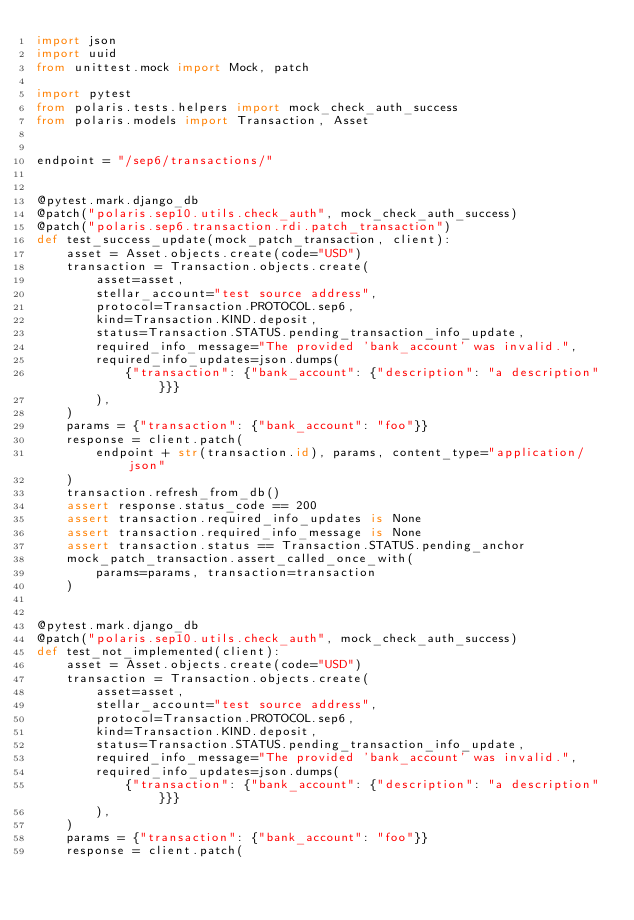<code> <loc_0><loc_0><loc_500><loc_500><_Python_>import json
import uuid
from unittest.mock import Mock, patch

import pytest
from polaris.tests.helpers import mock_check_auth_success
from polaris.models import Transaction, Asset


endpoint = "/sep6/transactions/"


@pytest.mark.django_db
@patch("polaris.sep10.utils.check_auth", mock_check_auth_success)
@patch("polaris.sep6.transaction.rdi.patch_transaction")
def test_success_update(mock_patch_transaction, client):
    asset = Asset.objects.create(code="USD")
    transaction = Transaction.objects.create(
        asset=asset,
        stellar_account="test source address",
        protocol=Transaction.PROTOCOL.sep6,
        kind=Transaction.KIND.deposit,
        status=Transaction.STATUS.pending_transaction_info_update,
        required_info_message="The provided 'bank_account' was invalid.",
        required_info_updates=json.dumps(
            {"transaction": {"bank_account": {"description": "a description"}}}
        ),
    )
    params = {"transaction": {"bank_account": "foo"}}
    response = client.patch(
        endpoint + str(transaction.id), params, content_type="application/json"
    )
    transaction.refresh_from_db()
    assert response.status_code == 200
    assert transaction.required_info_updates is None
    assert transaction.required_info_message is None
    assert transaction.status == Transaction.STATUS.pending_anchor
    mock_patch_transaction.assert_called_once_with(
        params=params, transaction=transaction
    )


@pytest.mark.django_db
@patch("polaris.sep10.utils.check_auth", mock_check_auth_success)
def test_not_implemented(client):
    asset = Asset.objects.create(code="USD")
    transaction = Transaction.objects.create(
        asset=asset,
        stellar_account="test source address",
        protocol=Transaction.PROTOCOL.sep6,
        kind=Transaction.KIND.deposit,
        status=Transaction.STATUS.pending_transaction_info_update,
        required_info_message="The provided 'bank_account' was invalid.",
        required_info_updates=json.dumps(
            {"transaction": {"bank_account": {"description": "a description"}}}
        ),
    )
    params = {"transaction": {"bank_account": "foo"}}
    response = client.patch(</code> 